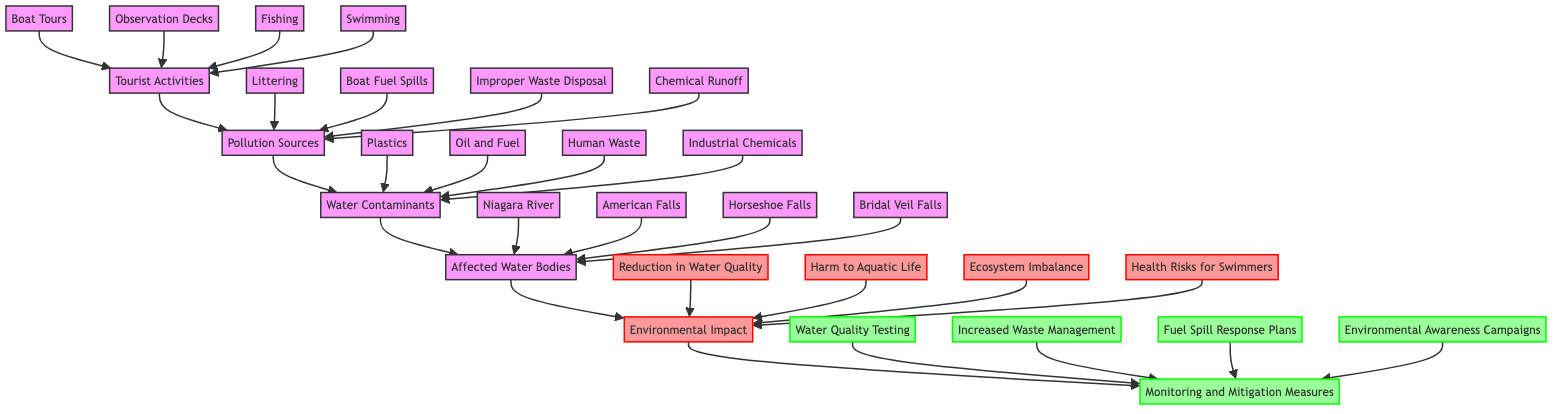What are the four types of tourist activities listed? From the "Tourist Activities" node in the diagram, I can see that it branches out to four specific activities: Boat Tours, Observation Decks, Fishing, and Swimming.
Answer: Boat Tours, Observation Decks, Fishing, Swimming How many pollution sources are identified? The "Pollution Sources" node has four branches leading to various sources: Littering, Boat Fuel Spills, Improper Waste Disposal, and Chemical Runoff. Hence, there are four pollution sources listed.
Answer: 4 What type of contaminants are derived from pollution sources? The "Water Contaminants" node has branches to four types of contaminants that stem from the pollution sources: Plastics, Oil and Fuel, Human Waste, and Industrial Chemicals.
Answer: Plastics, Oil and Fuel, Human Waste, Industrial Chemicals Which water bodies are affected as per the diagram? The "Affected Water Bodies" node indicates four bodies: Niagara River, American Falls, Horseshoe Falls, and Bridal Veil Falls, which leads to understanding the impact of tourism on these locations.
Answer: Niagara River, American Falls, Horseshoe Falls, Bridal Veil Falls What is one significant environmental impact listed in the diagram? From the "Environmental Impact" node, it lists four impacts among which one significant impact is "Harm to Aquatic Life." This indicates how tourism can affect local ecosystems.
Answer: Harm to Aquatic Life What are the mitigation measures suggested in the diagram? The "Monitoring and Mitigation Measures" node lists four strategies to mitigate the impacts, including Water Quality Testing, Increased Waste Management, Fuel Spill Response Plans, and Environmental Awareness Campaigns.
Answer: Water Quality Testing, Increased Waste Management, Fuel Spill Response Plans, Environmental Awareness Campaigns How do tourist activities lead to pollution sources? The flow from "Tourist Activities" to "Pollution Sources" indicates that various activities create pollution through means such as littering or boat fuel spills, hence causing environmental degradation.
Answer: Pollution occurs through littering, fuel spills, etc What is the primary direction of the flow in the diagram? The diagram flows from "Tourist Activities" to "Pollution Sources," then to "Water Contaminants," followed by "Affected Water Bodies," which finally leads to "Environmental Impact" and ends at "Monitoring and Mitigation Measures." This demonstrates the sequential relationship of how tourism affects water quality.
Answer: From Tourist Activities to Monitoring and Mitigation Measures 